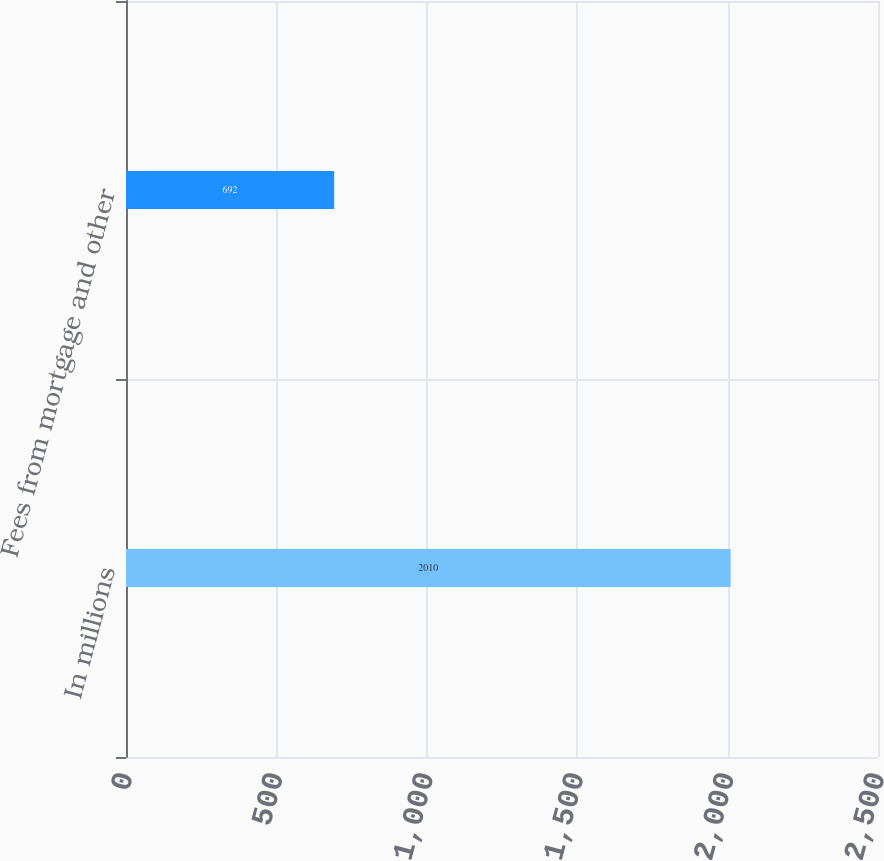Convert chart to OTSL. <chart><loc_0><loc_0><loc_500><loc_500><bar_chart><fcel>In millions<fcel>Fees from mortgage and other<nl><fcel>2010<fcel>692<nl></chart> 